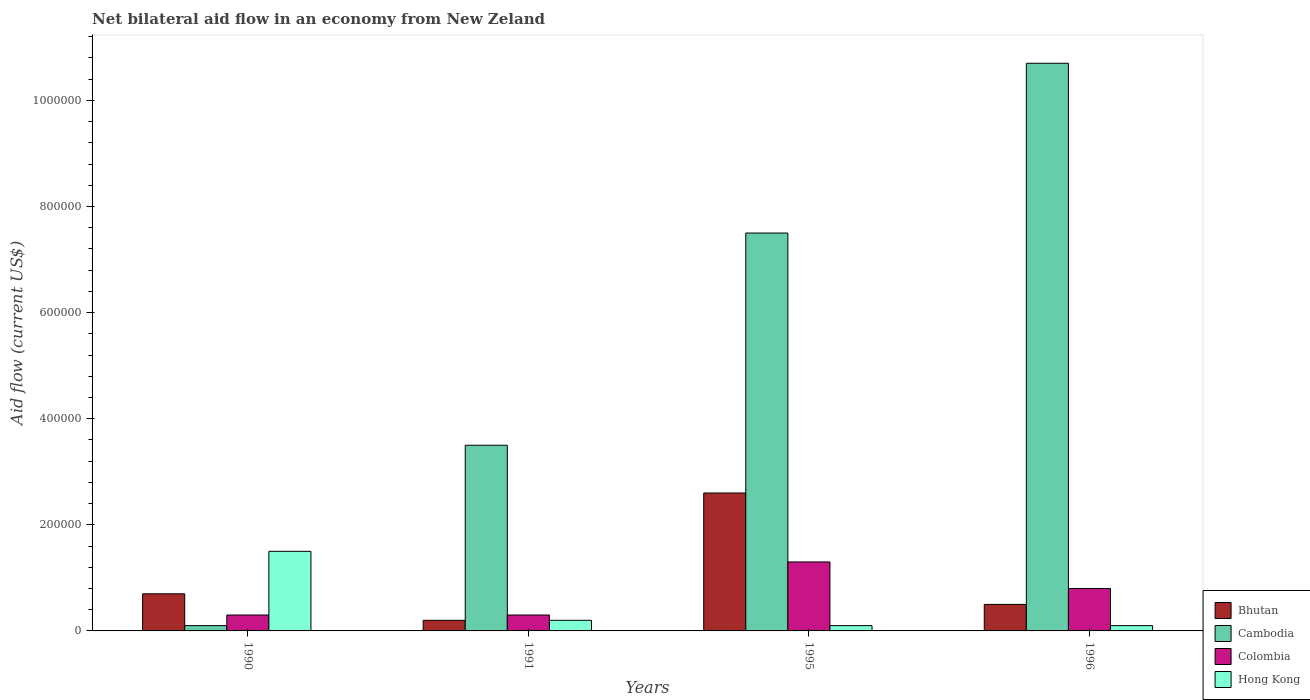Are the number of bars per tick equal to the number of legend labels?
Provide a succinct answer. Yes. How many bars are there on the 1st tick from the right?
Offer a very short reply. 4. What is the label of the 1st group of bars from the left?
Give a very brief answer. 1990. In how many cases, is the number of bars for a given year not equal to the number of legend labels?
Provide a short and direct response. 0. What is the net bilateral aid flow in Cambodia in 1996?
Ensure brevity in your answer.  1.07e+06. Across all years, what is the maximum net bilateral aid flow in Cambodia?
Your response must be concise. 1.07e+06. In which year was the net bilateral aid flow in Colombia minimum?
Your response must be concise. 1990. What is the difference between the net bilateral aid flow in Cambodia in 1991 and that in 1995?
Give a very brief answer. -4.00e+05. What is the average net bilateral aid flow in Bhutan per year?
Your answer should be compact. 1.00e+05. In the year 1996, what is the difference between the net bilateral aid flow in Bhutan and net bilateral aid flow in Colombia?
Your response must be concise. -3.00e+04. What is the ratio of the net bilateral aid flow in Hong Kong in 1995 to that in 1996?
Your answer should be compact. 1. Is the difference between the net bilateral aid flow in Bhutan in 1991 and 1995 greater than the difference between the net bilateral aid flow in Colombia in 1991 and 1995?
Give a very brief answer. No. What is the difference between the highest and the lowest net bilateral aid flow in Hong Kong?
Provide a succinct answer. 1.40e+05. In how many years, is the net bilateral aid flow in Hong Kong greater than the average net bilateral aid flow in Hong Kong taken over all years?
Your response must be concise. 1. Is it the case that in every year, the sum of the net bilateral aid flow in Colombia and net bilateral aid flow in Bhutan is greater than the sum of net bilateral aid flow in Hong Kong and net bilateral aid flow in Cambodia?
Ensure brevity in your answer.  No. What does the 2nd bar from the left in 1996 represents?
Offer a very short reply. Cambodia. What does the 4th bar from the right in 1996 represents?
Your answer should be very brief. Bhutan. Are all the bars in the graph horizontal?
Provide a succinct answer. No. How many years are there in the graph?
Give a very brief answer. 4. Are the values on the major ticks of Y-axis written in scientific E-notation?
Your response must be concise. No. Where does the legend appear in the graph?
Offer a very short reply. Bottom right. How many legend labels are there?
Make the answer very short. 4. What is the title of the graph?
Provide a short and direct response. Net bilateral aid flow in an economy from New Zeland. Does "Moldova" appear as one of the legend labels in the graph?
Give a very brief answer. No. What is the label or title of the X-axis?
Your answer should be compact. Years. What is the Aid flow (current US$) in Colombia in 1990?
Provide a succinct answer. 3.00e+04. What is the Aid flow (current US$) in Colombia in 1991?
Provide a succinct answer. 3.00e+04. What is the Aid flow (current US$) in Hong Kong in 1991?
Provide a short and direct response. 2.00e+04. What is the Aid flow (current US$) of Cambodia in 1995?
Make the answer very short. 7.50e+05. What is the Aid flow (current US$) of Hong Kong in 1995?
Your answer should be compact. 10000. What is the Aid flow (current US$) in Cambodia in 1996?
Your answer should be compact. 1.07e+06. Across all years, what is the maximum Aid flow (current US$) in Bhutan?
Offer a terse response. 2.60e+05. Across all years, what is the maximum Aid flow (current US$) of Cambodia?
Ensure brevity in your answer.  1.07e+06. Across all years, what is the maximum Aid flow (current US$) in Colombia?
Your response must be concise. 1.30e+05. Across all years, what is the maximum Aid flow (current US$) in Hong Kong?
Make the answer very short. 1.50e+05. Across all years, what is the minimum Aid flow (current US$) in Bhutan?
Ensure brevity in your answer.  2.00e+04. Across all years, what is the minimum Aid flow (current US$) in Cambodia?
Offer a terse response. 10000. Across all years, what is the minimum Aid flow (current US$) of Colombia?
Offer a terse response. 3.00e+04. Across all years, what is the minimum Aid flow (current US$) of Hong Kong?
Offer a terse response. 10000. What is the total Aid flow (current US$) of Bhutan in the graph?
Offer a very short reply. 4.00e+05. What is the total Aid flow (current US$) of Cambodia in the graph?
Your answer should be very brief. 2.18e+06. What is the total Aid flow (current US$) of Colombia in the graph?
Your response must be concise. 2.70e+05. What is the difference between the Aid flow (current US$) in Bhutan in 1990 and that in 1995?
Offer a terse response. -1.90e+05. What is the difference between the Aid flow (current US$) of Cambodia in 1990 and that in 1995?
Provide a short and direct response. -7.40e+05. What is the difference between the Aid flow (current US$) in Bhutan in 1990 and that in 1996?
Offer a terse response. 2.00e+04. What is the difference between the Aid flow (current US$) in Cambodia in 1990 and that in 1996?
Offer a terse response. -1.06e+06. What is the difference between the Aid flow (current US$) of Colombia in 1990 and that in 1996?
Ensure brevity in your answer.  -5.00e+04. What is the difference between the Aid flow (current US$) in Cambodia in 1991 and that in 1995?
Your response must be concise. -4.00e+05. What is the difference between the Aid flow (current US$) in Colombia in 1991 and that in 1995?
Your answer should be compact. -1.00e+05. What is the difference between the Aid flow (current US$) of Hong Kong in 1991 and that in 1995?
Keep it short and to the point. 10000. What is the difference between the Aid flow (current US$) in Cambodia in 1991 and that in 1996?
Your response must be concise. -7.20e+05. What is the difference between the Aid flow (current US$) in Colombia in 1991 and that in 1996?
Your answer should be very brief. -5.00e+04. What is the difference between the Aid flow (current US$) of Hong Kong in 1991 and that in 1996?
Offer a very short reply. 10000. What is the difference between the Aid flow (current US$) in Cambodia in 1995 and that in 1996?
Offer a terse response. -3.20e+05. What is the difference between the Aid flow (current US$) in Colombia in 1995 and that in 1996?
Make the answer very short. 5.00e+04. What is the difference between the Aid flow (current US$) of Bhutan in 1990 and the Aid flow (current US$) of Cambodia in 1991?
Your response must be concise. -2.80e+05. What is the difference between the Aid flow (current US$) in Bhutan in 1990 and the Aid flow (current US$) in Colombia in 1991?
Provide a short and direct response. 4.00e+04. What is the difference between the Aid flow (current US$) of Bhutan in 1990 and the Aid flow (current US$) of Hong Kong in 1991?
Ensure brevity in your answer.  5.00e+04. What is the difference between the Aid flow (current US$) of Cambodia in 1990 and the Aid flow (current US$) of Hong Kong in 1991?
Provide a short and direct response. -10000. What is the difference between the Aid flow (current US$) in Bhutan in 1990 and the Aid flow (current US$) in Cambodia in 1995?
Your answer should be compact. -6.80e+05. What is the difference between the Aid flow (current US$) in Bhutan in 1990 and the Aid flow (current US$) in Hong Kong in 1995?
Make the answer very short. 6.00e+04. What is the difference between the Aid flow (current US$) of Cambodia in 1990 and the Aid flow (current US$) of Hong Kong in 1995?
Keep it short and to the point. 0. What is the difference between the Aid flow (current US$) of Colombia in 1990 and the Aid flow (current US$) of Hong Kong in 1995?
Make the answer very short. 2.00e+04. What is the difference between the Aid flow (current US$) of Bhutan in 1990 and the Aid flow (current US$) of Cambodia in 1996?
Provide a succinct answer. -1.00e+06. What is the difference between the Aid flow (current US$) in Bhutan in 1991 and the Aid flow (current US$) in Cambodia in 1995?
Ensure brevity in your answer.  -7.30e+05. What is the difference between the Aid flow (current US$) in Bhutan in 1991 and the Aid flow (current US$) in Colombia in 1995?
Your answer should be very brief. -1.10e+05. What is the difference between the Aid flow (current US$) of Cambodia in 1991 and the Aid flow (current US$) of Colombia in 1995?
Offer a terse response. 2.20e+05. What is the difference between the Aid flow (current US$) in Colombia in 1991 and the Aid flow (current US$) in Hong Kong in 1995?
Offer a very short reply. 2.00e+04. What is the difference between the Aid flow (current US$) in Bhutan in 1991 and the Aid flow (current US$) in Cambodia in 1996?
Keep it short and to the point. -1.05e+06. What is the difference between the Aid flow (current US$) of Bhutan in 1991 and the Aid flow (current US$) of Colombia in 1996?
Your answer should be very brief. -6.00e+04. What is the difference between the Aid flow (current US$) of Bhutan in 1991 and the Aid flow (current US$) of Hong Kong in 1996?
Offer a very short reply. 10000. What is the difference between the Aid flow (current US$) of Cambodia in 1991 and the Aid flow (current US$) of Hong Kong in 1996?
Provide a short and direct response. 3.40e+05. What is the difference between the Aid flow (current US$) of Bhutan in 1995 and the Aid flow (current US$) of Cambodia in 1996?
Offer a terse response. -8.10e+05. What is the difference between the Aid flow (current US$) in Bhutan in 1995 and the Aid flow (current US$) in Hong Kong in 1996?
Offer a terse response. 2.50e+05. What is the difference between the Aid flow (current US$) of Cambodia in 1995 and the Aid flow (current US$) of Colombia in 1996?
Keep it short and to the point. 6.70e+05. What is the difference between the Aid flow (current US$) in Cambodia in 1995 and the Aid flow (current US$) in Hong Kong in 1996?
Provide a short and direct response. 7.40e+05. What is the difference between the Aid flow (current US$) of Colombia in 1995 and the Aid flow (current US$) of Hong Kong in 1996?
Offer a terse response. 1.20e+05. What is the average Aid flow (current US$) in Bhutan per year?
Your answer should be very brief. 1.00e+05. What is the average Aid flow (current US$) of Cambodia per year?
Offer a terse response. 5.45e+05. What is the average Aid flow (current US$) of Colombia per year?
Your answer should be compact. 6.75e+04. What is the average Aid flow (current US$) in Hong Kong per year?
Provide a short and direct response. 4.75e+04. In the year 1990, what is the difference between the Aid flow (current US$) of Bhutan and Aid flow (current US$) of Hong Kong?
Offer a very short reply. -8.00e+04. In the year 1990, what is the difference between the Aid flow (current US$) in Cambodia and Aid flow (current US$) in Hong Kong?
Keep it short and to the point. -1.40e+05. In the year 1991, what is the difference between the Aid flow (current US$) in Bhutan and Aid flow (current US$) in Cambodia?
Provide a succinct answer. -3.30e+05. In the year 1991, what is the difference between the Aid flow (current US$) in Bhutan and Aid flow (current US$) in Hong Kong?
Give a very brief answer. 0. In the year 1991, what is the difference between the Aid flow (current US$) in Cambodia and Aid flow (current US$) in Hong Kong?
Keep it short and to the point. 3.30e+05. In the year 1995, what is the difference between the Aid flow (current US$) of Bhutan and Aid flow (current US$) of Cambodia?
Keep it short and to the point. -4.90e+05. In the year 1995, what is the difference between the Aid flow (current US$) in Bhutan and Aid flow (current US$) in Colombia?
Ensure brevity in your answer.  1.30e+05. In the year 1995, what is the difference between the Aid flow (current US$) of Bhutan and Aid flow (current US$) of Hong Kong?
Offer a terse response. 2.50e+05. In the year 1995, what is the difference between the Aid flow (current US$) in Cambodia and Aid flow (current US$) in Colombia?
Your answer should be very brief. 6.20e+05. In the year 1995, what is the difference between the Aid flow (current US$) of Cambodia and Aid flow (current US$) of Hong Kong?
Your response must be concise. 7.40e+05. In the year 1996, what is the difference between the Aid flow (current US$) in Bhutan and Aid flow (current US$) in Cambodia?
Give a very brief answer. -1.02e+06. In the year 1996, what is the difference between the Aid flow (current US$) of Bhutan and Aid flow (current US$) of Colombia?
Ensure brevity in your answer.  -3.00e+04. In the year 1996, what is the difference between the Aid flow (current US$) of Bhutan and Aid flow (current US$) of Hong Kong?
Provide a succinct answer. 4.00e+04. In the year 1996, what is the difference between the Aid flow (current US$) of Cambodia and Aid flow (current US$) of Colombia?
Give a very brief answer. 9.90e+05. In the year 1996, what is the difference between the Aid flow (current US$) in Cambodia and Aid flow (current US$) in Hong Kong?
Offer a terse response. 1.06e+06. What is the ratio of the Aid flow (current US$) in Bhutan in 1990 to that in 1991?
Offer a very short reply. 3.5. What is the ratio of the Aid flow (current US$) in Cambodia in 1990 to that in 1991?
Keep it short and to the point. 0.03. What is the ratio of the Aid flow (current US$) in Bhutan in 1990 to that in 1995?
Give a very brief answer. 0.27. What is the ratio of the Aid flow (current US$) of Cambodia in 1990 to that in 1995?
Keep it short and to the point. 0.01. What is the ratio of the Aid flow (current US$) of Colombia in 1990 to that in 1995?
Ensure brevity in your answer.  0.23. What is the ratio of the Aid flow (current US$) in Hong Kong in 1990 to that in 1995?
Ensure brevity in your answer.  15. What is the ratio of the Aid flow (current US$) in Cambodia in 1990 to that in 1996?
Make the answer very short. 0.01. What is the ratio of the Aid flow (current US$) in Colombia in 1990 to that in 1996?
Your response must be concise. 0.38. What is the ratio of the Aid flow (current US$) of Bhutan in 1991 to that in 1995?
Offer a very short reply. 0.08. What is the ratio of the Aid flow (current US$) of Cambodia in 1991 to that in 1995?
Make the answer very short. 0.47. What is the ratio of the Aid flow (current US$) of Colombia in 1991 to that in 1995?
Offer a very short reply. 0.23. What is the ratio of the Aid flow (current US$) in Hong Kong in 1991 to that in 1995?
Make the answer very short. 2. What is the ratio of the Aid flow (current US$) of Bhutan in 1991 to that in 1996?
Make the answer very short. 0.4. What is the ratio of the Aid flow (current US$) of Cambodia in 1991 to that in 1996?
Your answer should be very brief. 0.33. What is the ratio of the Aid flow (current US$) in Colombia in 1991 to that in 1996?
Your response must be concise. 0.38. What is the ratio of the Aid flow (current US$) of Bhutan in 1995 to that in 1996?
Make the answer very short. 5.2. What is the ratio of the Aid flow (current US$) in Cambodia in 1995 to that in 1996?
Make the answer very short. 0.7. What is the ratio of the Aid flow (current US$) of Colombia in 1995 to that in 1996?
Provide a short and direct response. 1.62. What is the difference between the highest and the second highest Aid flow (current US$) in Colombia?
Make the answer very short. 5.00e+04. What is the difference between the highest and the second highest Aid flow (current US$) in Hong Kong?
Offer a very short reply. 1.30e+05. What is the difference between the highest and the lowest Aid flow (current US$) of Cambodia?
Give a very brief answer. 1.06e+06. 